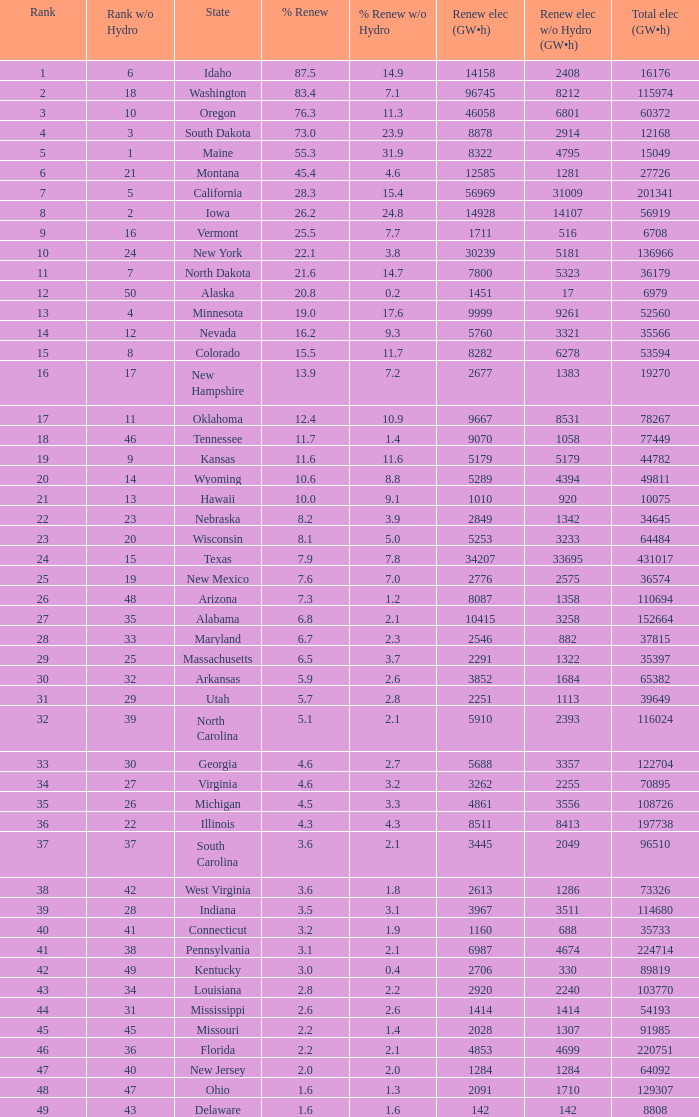When renewable electricity is 5760 (gw×h) what is the minimum amount of renewable elecrrixity without hydrogen power? 3321.0. 